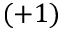Convert formula to latex. <formula><loc_0><loc_0><loc_500><loc_500>( + 1 )</formula> 